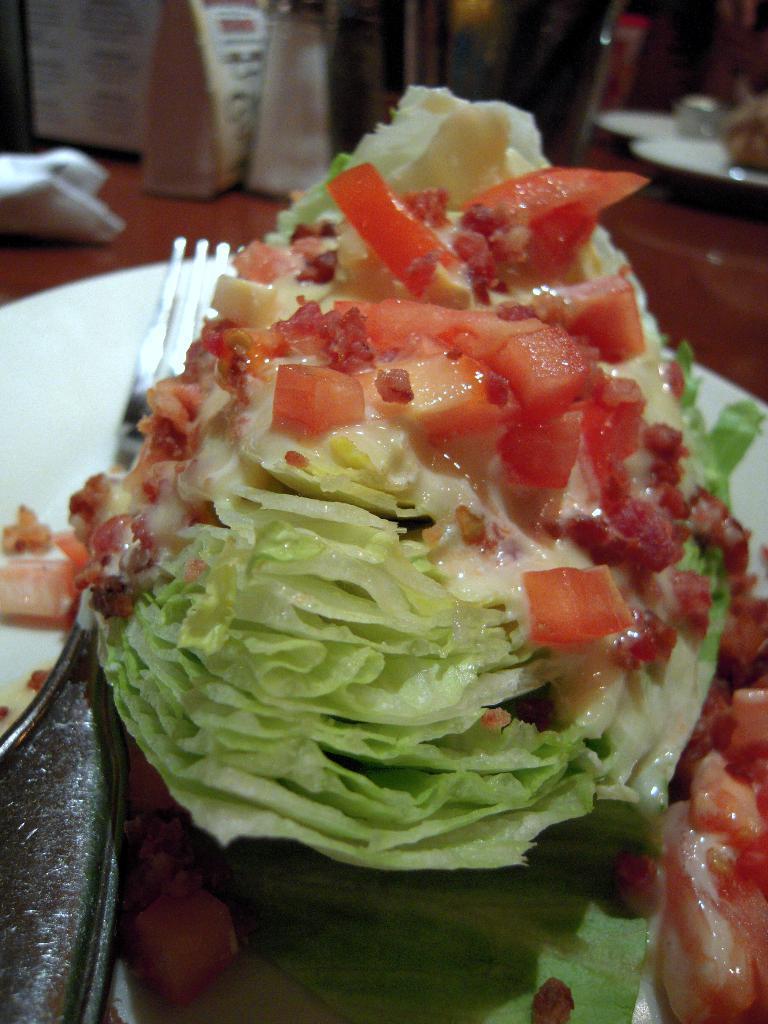How would you summarize this image in a sentence or two? In the center of the image we can see one table. On the table,we can see plates,banners,one fork,some food items and few other objects. 